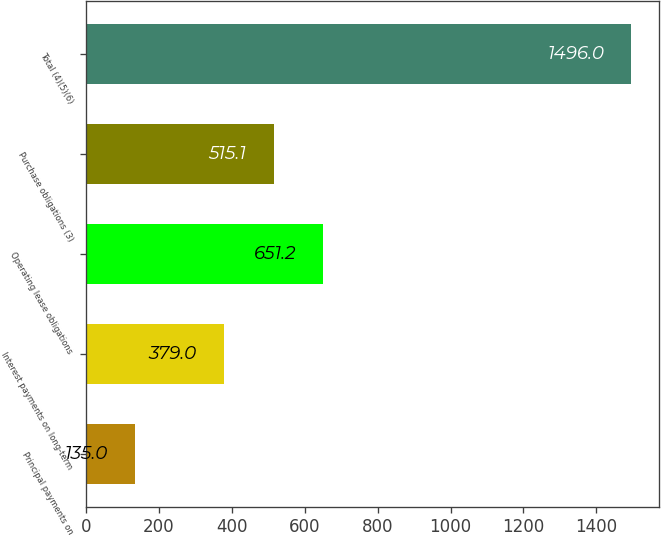Convert chart to OTSL. <chart><loc_0><loc_0><loc_500><loc_500><bar_chart><fcel>Principal payments on<fcel>Interest payments on long-term<fcel>Operating lease obligations<fcel>Purchase obligations (3)<fcel>Total (4)(5)(6)<nl><fcel>135<fcel>379<fcel>651.2<fcel>515.1<fcel>1496<nl></chart> 